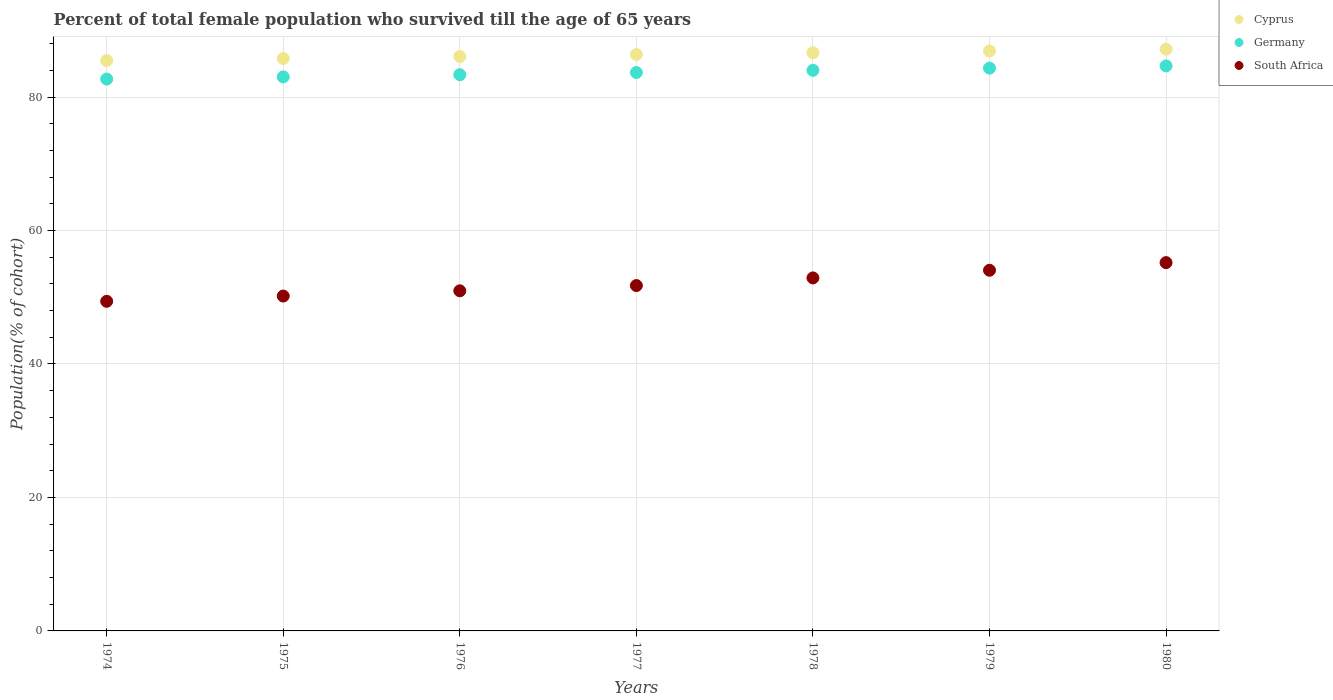How many different coloured dotlines are there?
Offer a terse response. 3. What is the percentage of total female population who survived till the age of 65 years in Cyprus in 1979?
Your answer should be very brief. 86.91. Across all years, what is the maximum percentage of total female population who survived till the age of 65 years in Germany?
Offer a very short reply. 84.66. Across all years, what is the minimum percentage of total female population who survived till the age of 65 years in Cyprus?
Give a very brief answer. 85.47. In which year was the percentage of total female population who survived till the age of 65 years in South Africa minimum?
Your response must be concise. 1974. What is the total percentage of total female population who survived till the age of 65 years in Germany in the graph?
Ensure brevity in your answer.  585.73. What is the difference between the percentage of total female population who survived till the age of 65 years in South Africa in 1974 and that in 1975?
Ensure brevity in your answer.  -0.79. What is the difference between the percentage of total female population who survived till the age of 65 years in South Africa in 1975 and the percentage of total female population who survived till the age of 65 years in Cyprus in 1977?
Give a very brief answer. -36.2. What is the average percentage of total female population who survived till the age of 65 years in Cyprus per year?
Offer a very short reply. 86.35. In the year 1979, what is the difference between the percentage of total female population who survived till the age of 65 years in Germany and percentage of total female population who survived till the age of 65 years in South Africa?
Keep it short and to the point. 30.29. In how many years, is the percentage of total female population who survived till the age of 65 years in South Africa greater than 72 %?
Provide a short and direct response. 0. What is the ratio of the percentage of total female population who survived till the age of 65 years in South Africa in 1976 to that in 1978?
Provide a succinct answer. 0.96. Is the percentage of total female population who survived till the age of 65 years in Germany in 1975 less than that in 1979?
Your answer should be compact. Yes. Is the difference between the percentage of total female population who survived till the age of 65 years in Germany in 1976 and 1977 greater than the difference between the percentage of total female population who survived till the age of 65 years in South Africa in 1976 and 1977?
Make the answer very short. Yes. What is the difference between the highest and the second highest percentage of total female population who survived till the age of 65 years in Cyprus?
Your answer should be very brief. 0.26. What is the difference between the highest and the lowest percentage of total female population who survived till the age of 65 years in South Africa?
Your answer should be compact. 5.8. Does the percentage of total female population who survived till the age of 65 years in Germany monotonically increase over the years?
Provide a succinct answer. Yes. Is the percentage of total female population who survived till the age of 65 years in Cyprus strictly greater than the percentage of total female population who survived till the age of 65 years in South Africa over the years?
Your response must be concise. Yes. Is the percentage of total female population who survived till the age of 65 years in South Africa strictly less than the percentage of total female population who survived till the age of 65 years in Cyprus over the years?
Make the answer very short. Yes. How many years are there in the graph?
Give a very brief answer. 7. What is the difference between two consecutive major ticks on the Y-axis?
Your response must be concise. 20. How many legend labels are there?
Offer a very short reply. 3. What is the title of the graph?
Offer a very short reply. Percent of total female population who survived till the age of 65 years. Does "Middle income" appear as one of the legend labels in the graph?
Your answer should be very brief. No. What is the label or title of the X-axis?
Offer a terse response. Years. What is the label or title of the Y-axis?
Ensure brevity in your answer.  Population(% of cohort). What is the Population(% of cohort) in Cyprus in 1974?
Make the answer very short. 85.47. What is the Population(% of cohort) of Germany in 1974?
Make the answer very short. 82.7. What is the Population(% of cohort) of South Africa in 1974?
Provide a short and direct response. 49.39. What is the Population(% of cohort) of Cyprus in 1975?
Make the answer very short. 85.77. What is the Population(% of cohort) of Germany in 1975?
Offer a terse response. 83.02. What is the Population(% of cohort) of South Africa in 1975?
Ensure brevity in your answer.  50.18. What is the Population(% of cohort) in Cyprus in 1976?
Ensure brevity in your answer.  86.08. What is the Population(% of cohort) in Germany in 1976?
Offer a very short reply. 83.35. What is the Population(% of cohort) in South Africa in 1976?
Provide a short and direct response. 50.96. What is the Population(% of cohort) of Cyprus in 1977?
Your answer should be very brief. 86.38. What is the Population(% of cohort) in Germany in 1977?
Keep it short and to the point. 83.67. What is the Population(% of cohort) in South Africa in 1977?
Provide a succinct answer. 51.75. What is the Population(% of cohort) of Cyprus in 1978?
Provide a short and direct response. 86.64. What is the Population(% of cohort) of Germany in 1978?
Provide a succinct answer. 84. What is the Population(% of cohort) in South Africa in 1978?
Offer a very short reply. 52.9. What is the Population(% of cohort) in Cyprus in 1979?
Make the answer very short. 86.91. What is the Population(% of cohort) of Germany in 1979?
Provide a short and direct response. 84.33. What is the Population(% of cohort) in South Africa in 1979?
Give a very brief answer. 54.04. What is the Population(% of cohort) in Cyprus in 1980?
Keep it short and to the point. 87.17. What is the Population(% of cohort) of Germany in 1980?
Make the answer very short. 84.66. What is the Population(% of cohort) of South Africa in 1980?
Provide a short and direct response. 55.19. Across all years, what is the maximum Population(% of cohort) in Cyprus?
Offer a terse response. 87.17. Across all years, what is the maximum Population(% of cohort) in Germany?
Give a very brief answer. 84.66. Across all years, what is the maximum Population(% of cohort) in South Africa?
Ensure brevity in your answer.  55.19. Across all years, what is the minimum Population(% of cohort) of Cyprus?
Offer a very short reply. 85.47. Across all years, what is the minimum Population(% of cohort) of Germany?
Give a very brief answer. 82.7. Across all years, what is the minimum Population(% of cohort) in South Africa?
Your answer should be compact. 49.39. What is the total Population(% of cohort) of Cyprus in the graph?
Provide a short and direct response. 604.43. What is the total Population(% of cohort) of Germany in the graph?
Your answer should be compact. 585.73. What is the total Population(% of cohort) in South Africa in the graph?
Ensure brevity in your answer.  364.42. What is the difference between the Population(% of cohort) in Cyprus in 1974 and that in 1975?
Offer a very short reply. -0.3. What is the difference between the Population(% of cohort) in Germany in 1974 and that in 1975?
Your answer should be very brief. -0.33. What is the difference between the Population(% of cohort) of South Africa in 1974 and that in 1975?
Your response must be concise. -0.79. What is the difference between the Population(% of cohort) of Cyprus in 1974 and that in 1976?
Your response must be concise. -0.61. What is the difference between the Population(% of cohort) of Germany in 1974 and that in 1976?
Offer a very short reply. -0.65. What is the difference between the Population(% of cohort) of South Africa in 1974 and that in 1976?
Provide a short and direct response. -1.57. What is the difference between the Population(% of cohort) in Cyprus in 1974 and that in 1977?
Your response must be concise. -0.91. What is the difference between the Population(% of cohort) in Germany in 1974 and that in 1977?
Provide a succinct answer. -0.98. What is the difference between the Population(% of cohort) of South Africa in 1974 and that in 1977?
Keep it short and to the point. -2.36. What is the difference between the Population(% of cohort) in Cyprus in 1974 and that in 1978?
Provide a short and direct response. -1.17. What is the difference between the Population(% of cohort) in Germany in 1974 and that in 1978?
Offer a terse response. -1.31. What is the difference between the Population(% of cohort) of South Africa in 1974 and that in 1978?
Your answer should be compact. -3.5. What is the difference between the Population(% of cohort) of Cyprus in 1974 and that in 1979?
Your response must be concise. -1.44. What is the difference between the Population(% of cohort) in Germany in 1974 and that in 1979?
Provide a succinct answer. -1.64. What is the difference between the Population(% of cohort) of South Africa in 1974 and that in 1979?
Your response must be concise. -4.65. What is the difference between the Population(% of cohort) in Cyprus in 1974 and that in 1980?
Offer a terse response. -1.7. What is the difference between the Population(% of cohort) of Germany in 1974 and that in 1980?
Your response must be concise. -1.96. What is the difference between the Population(% of cohort) of South Africa in 1974 and that in 1980?
Your response must be concise. -5.8. What is the difference between the Population(% of cohort) in Cyprus in 1975 and that in 1976?
Ensure brevity in your answer.  -0.3. What is the difference between the Population(% of cohort) in Germany in 1975 and that in 1976?
Your response must be concise. -0.33. What is the difference between the Population(% of cohort) of South Africa in 1975 and that in 1976?
Provide a short and direct response. -0.79. What is the difference between the Population(% of cohort) in Cyprus in 1975 and that in 1977?
Ensure brevity in your answer.  -0.61. What is the difference between the Population(% of cohort) in Germany in 1975 and that in 1977?
Provide a short and direct response. -0.65. What is the difference between the Population(% of cohort) in South Africa in 1975 and that in 1977?
Your answer should be very brief. -1.57. What is the difference between the Population(% of cohort) of Cyprus in 1975 and that in 1978?
Your response must be concise. -0.87. What is the difference between the Population(% of cohort) of Germany in 1975 and that in 1978?
Provide a short and direct response. -0.98. What is the difference between the Population(% of cohort) of South Africa in 1975 and that in 1978?
Your answer should be compact. -2.72. What is the difference between the Population(% of cohort) in Cyprus in 1975 and that in 1979?
Your answer should be very brief. -1.13. What is the difference between the Population(% of cohort) of Germany in 1975 and that in 1979?
Offer a very short reply. -1.31. What is the difference between the Population(% of cohort) of South Africa in 1975 and that in 1979?
Give a very brief answer. -3.86. What is the difference between the Population(% of cohort) of Cyprus in 1975 and that in 1980?
Offer a very short reply. -1.4. What is the difference between the Population(% of cohort) of Germany in 1975 and that in 1980?
Ensure brevity in your answer.  -1.64. What is the difference between the Population(% of cohort) in South Africa in 1975 and that in 1980?
Keep it short and to the point. -5.01. What is the difference between the Population(% of cohort) in Cyprus in 1976 and that in 1977?
Offer a terse response. -0.3. What is the difference between the Population(% of cohort) in Germany in 1976 and that in 1977?
Your answer should be compact. -0.33. What is the difference between the Population(% of cohort) of South Africa in 1976 and that in 1977?
Keep it short and to the point. -0.79. What is the difference between the Population(% of cohort) in Cyprus in 1976 and that in 1978?
Make the answer very short. -0.57. What is the difference between the Population(% of cohort) in Germany in 1976 and that in 1978?
Keep it short and to the point. -0.65. What is the difference between the Population(% of cohort) in South Africa in 1976 and that in 1978?
Offer a very short reply. -1.93. What is the difference between the Population(% of cohort) of Cyprus in 1976 and that in 1979?
Offer a terse response. -0.83. What is the difference between the Population(% of cohort) in Germany in 1976 and that in 1979?
Keep it short and to the point. -0.98. What is the difference between the Population(% of cohort) of South Africa in 1976 and that in 1979?
Your response must be concise. -3.08. What is the difference between the Population(% of cohort) of Cyprus in 1976 and that in 1980?
Your answer should be compact. -1.1. What is the difference between the Population(% of cohort) of Germany in 1976 and that in 1980?
Your answer should be very brief. -1.31. What is the difference between the Population(% of cohort) of South Africa in 1976 and that in 1980?
Ensure brevity in your answer.  -4.22. What is the difference between the Population(% of cohort) in Cyprus in 1977 and that in 1978?
Offer a terse response. -0.26. What is the difference between the Population(% of cohort) of Germany in 1977 and that in 1978?
Ensure brevity in your answer.  -0.33. What is the difference between the Population(% of cohort) in South Africa in 1977 and that in 1978?
Make the answer very short. -1.15. What is the difference between the Population(% of cohort) in Cyprus in 1977 and that in 1979?
Offer a very short reply. -0.53. What is the difference between the Population(% of cohort) of Germany in 1977 and that in 1979?
Your answer should be very brief. -0.66. What is the difference between the Population(% of cohort) of South Africa in 1977 and that in 1979?
Provide a short and direct response. -2.29. What is the difference between the Population(% of cohort) of Cyprus in 1977 and that in 1980?
Provide a succinct answer. -0.79. What is the difference between the Population(% of cohort) in Germany in 1977 and that in 1980?
Provide a succinct answer. -0.98. What is the difference between the Population(% of cohort) of South Africa in 1977 and that in 1980?
Ensure brevity in your answer.  -3.44. What is the difference between the Population(% of cohort) in Cyprus in 1978 and that in 1979?
Make the answer very short. -0.26. What is the difference between the Population(% of cohort) in Germany in 1978 and that in 1979?
Make the answer very short. -0.33. What is the difference between the Population(% of cohort) in South Africa in 1978 and that in 1979?
Provide a short and direct response. -1.15. What is the difference between the Population(% of cohort) of Cyprus in 1978 and that in 1980?
Offer a very short reply. -0.53. What is the difference between the Population(% of cohort) in Germany in 1978 and that in 1980?
Provide a short and direct response. -0.66. What is the difference between the Population(% of cohort) in South Africa in 1978 and that in 1980?
Give a very brief answer. -2.29. What is the difference between the Population(% of cohort) in Cyprus in 1979 and that in 1980?
Make the answer very short. -0.26. What is the difference between the Population(% of cohort) of Germany in 1979 and that in 1980?
Your answer should be very brief. -0.33. What is the difference between the Population(% of cohort) of South Africa in 1979 and that in 1980?
Provide a short and direct response. -1.15. What is the difference between the Population(% of cohort) of Cyprus in 1974 and the Population(% of cohort) of Germany in 1975?
Your answer should be compact. 2.45. What is the difference between the Population(% of cohort) in Cyprus in 1974 and the Population(% of cohort) in South Africa in 1975?
Offer a terse response. 35.29. What is the difference between the Population(% of cohort) of Germany in 1974 and the Population(% of cohort) of South Africa in 1975?
Keep it short and to the point. 32.52. What is the difference between the Population(% of cohort) in Cyprus in 1974 and the Population(% of cohort) in Germany in 1976?
Offer a very short reply. 2.12. What is the difference between the Population(% of cohort) of Cyprus in 1974 and the Population(% of cohort) of South Africa in 1976?
Provide a short and direct response. 34.51. What is the difference between the Population(% of cohort) in Germany in 1974 and the Population(% of cohort) in South Africa in 1976?
Give a very brief answer. 31.73. What is the difference between the Population(% of cohort) of Cyprus in 1974 and the Population(% of cohort) of Germany in 1977?
Your answer should be compact. 1.8. What is the difference between the Population(% of cohort) in Cyprus in 1974 and the Population(% of cohort) in South Africa in 1977?
Give a very brief answer. 33.72. What is the difference between the Population(% of cohort) of Germany in 1974 and the Population(% of cohort) of South Africa in 1977?
Your answer should be compact. 30.95. What is the difference between the Population(% of cohort) in Cyprus in 1974 and the Population(% of cohort) in Germany in 1978?
Give a very brief answer. 1.47. What is the difference between the Population(% of cohort) of Cyprus in 1974 and the Population(% of cohort) of South Africa in 1978?
Make the answer very short. 32.57. What is the difference between the Population(% of cohort) of Germany in 1974 and the Population(% of cohort) of South Africa in 1978?
Offer a very short reply. 29.8. What is the difference between the Population(% of cohort) of Cyprus in 1974 and the Population(% of cohort) of Germany in 1979?
Ensure brevity in your answer.  1.14. What is the difference between the Population(% of cohort) of Cyprus in 1974 and the Population(% of cohort) of South Africa in 1979?
Your response must be concise. 31.43. What is the difference between the Population(% of cohort) of Germany in 1974 and the Population(% of cohort) of South Africa in 1979?
Keep it short and to the point. 28.65. What is the difference between the Population(% of cohort) in Cyprus in 1974 and the Population(% of cohort) in Germany in 1980?
Your answer should be compact. 0.81. What is the difference between the Population(% of cohort) of Cyprus in 1974 and the Population(% of cohort) of South Africa in 1980?
Make the answer very short. 30.28. What is the difference between the Population(% of cohort) of Germany in 1974 and the Population(% of cohort) of South Africa in 1980?
Your answer should be very brief. 27.51. What is the difference between the Population(% of cohort) of Cyprus in 1975 and the Population(% of cohort) of Germany in 1976?
Ensure brevity in your answer.  2.43. What is the difference between the Population(% of cohort) of Cyprus in 1975 and the Population(% of cohort) of South Africa in 1976?
Make the answer very short. 34.81. What is the difference between the Population(% of cohort) of Germany in 1975 and the Population(% of cohort) of South Africa in 1976?
Offer a terse response. 32.06. What is the difference between the Population(% of cohort) in Cyprus in 1975 and the Population(% of cohort) in Germany in 1977?
Offer a very short reply. 2.1. What is the difference between the Population(% of cohort) of Cyprus in 1975 and the Population(% of cohort) of South Africa in 1977?
Provide a succinct answer. 34.02. What is the difference between the Population(% of cohort) of Germany in 1975 and the Population(% of cohort) of South Africa in 1977?
Ensure brevity in your answer.  31.27. What is the difference between the Population(% of cohort) of Cyprus in 1975 and the Population(% of cohort) of Germany in 1978?
Provide a short and direct response. 1.77. What is the difference between the Population(% of cohort) in Cyprus in 1975 and the Population(% of cohort) in South Africa in 1978?
Your answer should be very brief. 32.88. What is the difference between the Population(% of cohort) in Germany in 1975 and the Population(% of cohort) in South Africa in 1978?
Provide a succinct answer. 30.13. What is the difference between the Population(% of cohort) in Cyprus in 1975 and the Population(% of cohort) in Germany in 1979?
Keep it short and to the point. 1.44. What is the difference between the Population(% of cohort) in Cyprus in 1975 and the Population(% of cohort) in South Africa in 1979?
Offer a terse response. 31.73. What is the difference between the Population(% of cohort) of Germany in 1975 and the Population(% of cohort) of South Africa in 1979?
Ensure brevity in your answer.  28.98. What is the difference between the Population(% of cohort) in Cyprus in 1975 and the Population(% of cohort) in Germany in 1980?
Give a very brief answer. 1.11. What is the difference between the Population(% of cohort) of Cyprus in 1975 and the Population(% of cohort) of South Africa in 1980?
Provide a succinct answer. 30.58. What is the difference between the Population(% of cohort) of Germany in 1975 and the Population(% of cohort) of South Africa in 1980?
Provide a short and direct response. 27.83. What is the difference between the Population(% of cohort) of Cyprus in 1976 and the Population(% of cohort) of Germany in 1977?
Offer a very short reply. 2.4. What is the difference between the Population(% of cohort) in Cyprus in 1976 and the Population(% of cohort) in South Africa in 1977?
Offer a very short reply. 34.33. What is the difference between the Population(% of cohort) of Germany in 1976 and the Population(% of cohort) of South Africa in 1977?
Make the answer very short. 31.6. What is the difference between the Population(% of cohort) of Cyprus in 1976 and the Population(% of cohort) of Germany in 1978?
Provide a short and direct response. 2.07. What is the difference between the Population(% of cohort) in Cyprus in 1976 and the Population(% of cohort) in South Africa in 1978?
Provide a succinct answer. 33.18. What is the difference between the Population(% of cohort) of Germany in 1976 and the Population(% of cohort) of South Africa in 1978?
Provide a succinct answer. 30.45. What is the difference between the Population(% of cohort) of Cyprus in 1976 and the Population(% of cohort) of Germany in 1979?
Keep it short and to the point. 1.75. What is the difference between the Population(% of cohort) of Cyprus in 1976 and the Population(% of cohort) of South Africa in 1979?
Offer a terse response. 32.03. What is the difference between the Population(% of cohort) in Germany in 1976 and the Population(% of cohort) in South Africa in 1979?
Keep it short and to the point. 29.31. What is the difference between the Population(% of cohort) of Cyprus in 1976 and the Population(% of cohort) of Germany in 1980?
Provide a succinct answer. 1.42. What is the difference between the Population(% of cohort) of Cyprus in 1976 and the Population(% of cohort) of South Africa in 1980?
Provide a short and direct response. 30.89. What is the difference between the Population(% of cohort) in Germany in 1976 and the Population(% of cohort) in South Africa in 1980?
Your answer should be very brief. 28.16. What is the difference between the Population(% of cohort) of Cyprus in 1977 and the Population(% of cohort) of Germany in 1978?
Offer a terse response. 2.38. What is the difference between the Population(% of cohort) of Cyprus in 1977 and the Population(% of cohort) of South Africa in 1978?
Make the answer very short. 33.48. What is the difference between the Population(% of cohort) of Germany in 1977 and the Population(% of cohort) of South Africa in 1978?
Offer a very short reply. 30.78. What is the difference between the Population(% of cohort) of Cyprus in 1977 and the Population(% of cohort) of Germany in 1979?
Provide a succinct answer. 2.05. What is the difference between the Population(% of cohort) of Cyprus in 1977 and the Population(% of cohort) of South Africa in 1979?
Ensure brevity in your answer.  32.34. What is the difference between the Population(% of cohort) of Germany in 1977 and the Population(% of cohort) of South Africa in 1979?
Ensure brevity in your answer.  29.63. What is the difference between the Population(% of cohort) in Cyprus in 1977 and the Population(% of cohort) in Germany in 1980?
Offer a terse response. 1.72. What is the difference between the Population(% of cohort) of Cyprus in 1977 and the Population(% of cohort) of South Africa in 1980?
Provide a short and direct response. 31.19. What is the difference between the Population(% of cohort) in Germany in 1977 and the Population(% of cohort) in South Africa in 1980?
Provide a short and direct response. 28.49. What is the difference between the Population(% of cohort) in Cyprus in 1978 and the Population(% of cohort) in Germany in 1979?
Give a very brief answer. 2.31. What is the difference between the Population(% of cohort) in Cyprus in 1978 and the Population(% of cohort) in South Africa in 1979?
Offer a terse response. 32.6. What is the difference between the Population(% of cohort) of Germany in 1978 and the Population(% of cohort) of South Africa in 1979?
Ensure brevity in your answer.  29.96. What is the difference between the Population(% of cohort) in Cyprus in 1978 and the Population(% of cohort) in Germany in 1980?
Provide a short and direct response. 1.99. What is the difference between the Population(% of cohort) in Cyprus in 1978 and the Population(% of cohort) in South Africa in 1980?
Your answer should be very brief. 31.45. What is the difference between the Population(% of cohort) in Germany in 1978 and the Population(% of cohort) in South Africa in 1980?
Provide a succinct answer. 28.81. What is the difference between the Population(% of cohort) of Cyprus in 1979 and the Population(% of cohort) of Germany in 1980?
Provide a short and direct response. 2.25. What is the difference between the Population(% of cohort) in Cyprus in 1979 and the Population(% of cohort) in South Africa in 1980?
Provide a succinct answer. 31.72. What is the difference between the Population(% of cohort) in Germany in 1979 and the Population(% of cohort) in South Africa in 1980?
Ensure brevity in your answer.  29.14. What is the average Population(% of cohort) in Cyprus per year?
Keep it short and to the point. 86.35. What is the average Population(% of cohort) of Germany per year?
Provide a succinct answer. 83.68. What is the average Population(% of cohort) in South Africa per year?
Offer a terse response. 52.06. In the year 1974, what is the difference between the Population(% of cohort) in Cyprus and Population(% of cohort) in Germany?
Your response must be concise. 2.78. In the year 1974, what is the difference between the Population(% of cohort) in Cyprus and Population(% of cohort) in South Africa?
Your answer should be very brief. 36.08. In the year 1974, what is the difference between the Population(% of cohort) in Germany and Population(% of cohort) in South Africa?
Provide a short and direct response. 33.3. In the year 1975, what is the difference between the Population(% of cohort) in Cyprus and Population(% of cohort) in Germany?
Give a very brief answer. 2.75. In the year 1975, what is the difference between the Population(% of cohort) of Cyprus and Population(% of cohort) of South Africa?
Offer a terse response. 35.6. In the year 1975, what is the difference between the Population(% of cohort) of Germany and Population(% of cohort) of South Africa?
Keep it short and to the point. 32.84. In the year 1976, what is the difference between the Population(% of cohort) in Cyprus and Population(% of cohort) in Germany?
Keep it short and to the point. 2.73. In the year 1976, what is the difference between the Population(% of cohort) in Cyprus and Population(% of cohort) in South Africa?
Make the answer very short. 35.11. In the year 1976, what is the difference between the Population(% of cohort) in Germany and Population(% of cohort) in South Africa?
Your answer should be very brief. 32.38. In the year 1977, what is the difference between the Population(% of cohort) in Cyprus and Population(% of cohort) in Germany?
Your answer should be very brief. 2.71. In the year 1977, what is the difference between the Population(% of cohort) in Cyprus and Population(% of cohort) in South Africa?
Provide a succinct answer. 34.63. In the year 1977, what is the difference between the Population(% of cohort) of Germany and Population(% of cohort) of South Africa?
Your response must be concise. 31.92. In the year 1978, what is the difference between the Population(% of cohort) in Cyprus and Population(% of cohort) in Germany?
Give a very brief answer. 2.64. In the year 1978, what is the difference between the Population(% of cohort) in Cyprus and Population(% of cohort) in South Africa?
Provide a short and direct response. 33.75. In the year 1978, what is the difference between the Population(% of cohort) of Germany and Population(% of cohort) of South Africa?
Ensure brevity in your answer.  31.11. In the year 1979, what is the difference between the Population(% of cohort) in Cyprus and Population(% of cohort) in Germany?
Provide a short and direct response. 2.58. In the year 1979, what is the difference between the Population(% of cohort) in Cyprus and Population(% of cohort) in South Africa?
Your answer should be very brief. 32.87. In the year 1979, what is the difference between the Population(% of cohort) in Germany and Population(% of cohort) in South Africa?
Provide a short and direct response. 30.29. In the year 1980, what is the difference between the Population(% of cohort) in Cyprus and Population(% of cohort) in Germany?
Provide a short and direct response. 2.51. In the year 1980, what is the difference between the Population(% of cohort) of Cyprus and Population(% of cohort) of South Africa?
Ensure brevity in your answer.  31.98. In the year 1980, what is the difference between the Population(% of cohort) of Germany and Population(% of cohort) of South Africa?
Your answer should be compact. 29.47. What is the ratio of the Population(% of cohort) of Germany in 1974 to that in 1975?
Your answer should be compact. 1. What is the ratio of the Population(% of cohort) of South Africa in 1974 to that in 1975?
Ensure brevity in your answer.  0.98. What is the ratio of the Population(% of cohort) in South Africa in 1974 to that in 1976?
Offer a very short reply. 0.97. What is the ratio of the Population(% of cohort) in Cyprus in 1974 to that in 1977?
Your response must be concise. 0.99. What is the ratio of the Population(% of cohort) in Germany in 1974 to that in 1977?
Ensure brevity in your answer.  0.99. What is the ratio of the Population(% of cohort) in South Africa in 1974 to that in 1977?
Provide a succinct answer. 0.95. What is the ratio of the Population(% of cohort) in Cyprus in 1974 to that in 1978?
Make the answer very short. 0.99. What is the ratio of the Population(% of cohort) in Germany in 1974 to that in 1978?
Keep it short and to the point. 0.98. What is the ratio of the Population(% of cohort) in South Africa in 1974 to that in 1978?
Offer a very short reply. 0.93. What is the ratio of the Population(% of cohort) of Cyprus in 1974 to that in 1979?
Offer a terse response. 0.98. What is the ratio of the Population(% of cohort) of Germany in 1974 to that in 1979?
Your answer should be compact. 0.98. What is the ratio of the Population(% of cohort) in South Africa in 1974 to that in 1979?
Give a very brief answer. 0.91. What is the ratio of the Population(% of cohort) of Cyprus in 1974 to that in 1980?
Keep it short and to the point. 0.98. What is the ratio of the Population(% of cohort) of Germany in 1974 to that in 1980?
Keep it short and to the point. 0.98. What is the ratio of the Population(% of cohort) in South Africa in 1974 to that in 1980?
Offer a terse response. 0.9. What is the ratio of the Population(% of cohort) in South Africa in 1975 to that in 1976?
Give a very brief answer. 0.98. What is the ratio of the Population(% of cohort) of South Africa in 1975 to that in 1977?
Your answer should be compact. 0.97. What is the ratio of the Population(% of cohort) of Cyprus in 1975 to that in 1978?
Offer a terse response. 0.99. What is the ratio of the Population(% of cohort) of Germany in 1975 to that in 1978?
Ensure brevity in your answer.  0.99. What is the ratio of the Population(% of cohort) of South Africa in 1975 to that in 1978?
Make the answer very short. 0.95. What is the ratio of the Population(% of cohort) in Cyprus in 1975 to that in 1979?
Offer a terse response. 0.99. What is the ratio of the Population(% of cohort) of Germany in 1975 to that in 1979?
Keep it short and to the point. 0.98. What is the ratio of the Population(% of cohort) of South Africa in 1975 to that in 1979?
Offer a very short reply. 0.93. What is the ratio of the Population(% of cohort) of Cyprus in 1975 to that in 1980?
Your answer should be compact. 0.98. What is the ratio of the Population(% of cohort) in Germany in 1975 to that in 1980?
Your answer should be very brief. 0.98. What is the ratio of the Population(% of cohort) of South Africa in 1975 to that in 1980?
Give a very brief answer. 0.91. What is the ratio of the Population(% of cohort) of Germany in 1976 to that in 1977?
Give a very brief answer. 1. What is the ratio of the Population(% of cohort) of South Africa in 1976 to that in 1978?
Your answer should be very brief. 0.96. What is the ratio of the Population(% of cohort) of Germany in 1976 to that in 1979?
Give a very brief answer. 0.99. What is the ratio of the Population(% of cohort) of South Africa in 1976 to that in 1979?
Your response must be concise. 0.94. What is the ratio of the Population(% of cohort) in Cyprus in 1976 to that in 1980?
Your response must be concise. 0.99. What is the ratio of the Population(% of cohort) in Germany in 1976 to that in 1980?
Your answer should be very brief. 0.98. What is the ratio of the Population(% of cohort) in South Africa in 1976 to that in 1980?
Offer a very short reply. 0.92. What is the ratio of the Population(% of cohort) in South Africa in 1977 to that in 1978?
Give a very brief answer. 0.98. What is the ratio of the Population(% of cohort) in Cyprus in 1977 to that in 1979?
Offer a very short reply. 0.99. What is the ratio of the Population(% of cohort) of Germany in 1977 to that in 1979?
Provide a short and direct response. 0.99. What is the ratio of the Population(% of cohort) in South Africa in 1977 to that in 1979?
Provide a succinct answer. 0.96. What is the ratio of the Population(% of cohort) in Cyprus in 1977 to that in 1980?
Give a very brief answer. 0.99. What is the ratio of the Population(% of cohort) of Germany in 1977 to that in 1980?
Keep it short and to the point. 0.99. What is the ratio of the Population(% of cohort) in South Africa in 1977 to that in 1980?
Your answer should be very brief. 0.94. What is the ratio of the Population(% of cohort) in Cyprus in 1978 to that in 1979?
Provide a succinct answer. 1. What is the ratio of the Population(% of cohort) of South Africa in 1978 to that in 1979?
Your answer should be compact. 0.98. What is the ratio of the Population(% of cohort) in South Africa in 1978 to that in 1980?
Offer a very short reply. 0.96. What is the ratio of the Population(% of cohort) of Germany in 1979 to that in 1980?
Your answer should be very brief. 1. What is the ratio of the Population(% of cohort) in South Africa in 1979 to that in 1980?
Make the answer very short. 0.98. What is the difference between the highest and the second highest Population(% of cohort) in Cyprus?
Offer a terse response. 0.26. What is the difference between the highest and the second highest Population(% of cohort) of Germany?
Provide a succinct answer. 0.33. What is the difference between the highest and the second highest Population(% of cohort) in South Africa?
Offer a very short reply. 1.15. What is the difference between the highest and the lowest Population(% of cohort) of Cyprus?
Provide a succinct answer. 1.7. What is the difference between the highest and the lowest Population(% of cohort) of Germany?
Give a very brief answer. 1.96. What is the difference between the highest and the lowest Population(% of cohort) in South Africa?
Provide a succinct answer. 5.8. 